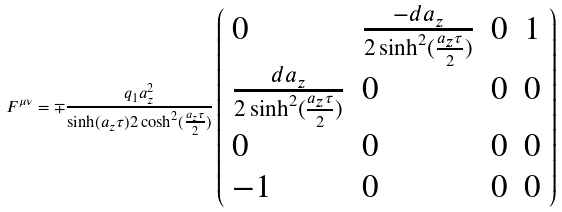<formula> <loc_0><loc_0><loc_500><loc_500>F ^ { \mu \nu } = \mp \frac { q _ { 1 } a _ { z } ^ { 2 } } { \sinh ( a _ { z } \tau ) 2 \cosh ^ { 2 } ( \frac { a _ { z } \tau } { 2 } ) } \left ( \begin{array} { l l l l } 0 & \frac { - d a _ { z } } { 2 \sinh ^ { 2 } ( \frac { a _ { z } \tau } { 2 } ) } & 0 & 1 \\ \frac { d a _ { z } } { 2 \sinh ^ { 2 } ( \frac { a _ { z } \tau } { 2 } ) } & 0 & 0 & 0 \\ 0 & 0 & 0 & 0 \\ - 1 & 0 & 0 & 0 \\ \end{array} \right )</formula> 